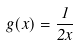<formula> <loc_0><loc_0><loc_500><loc_500>g ( x ) = \frac { 1 } { 2 x }</formula> 